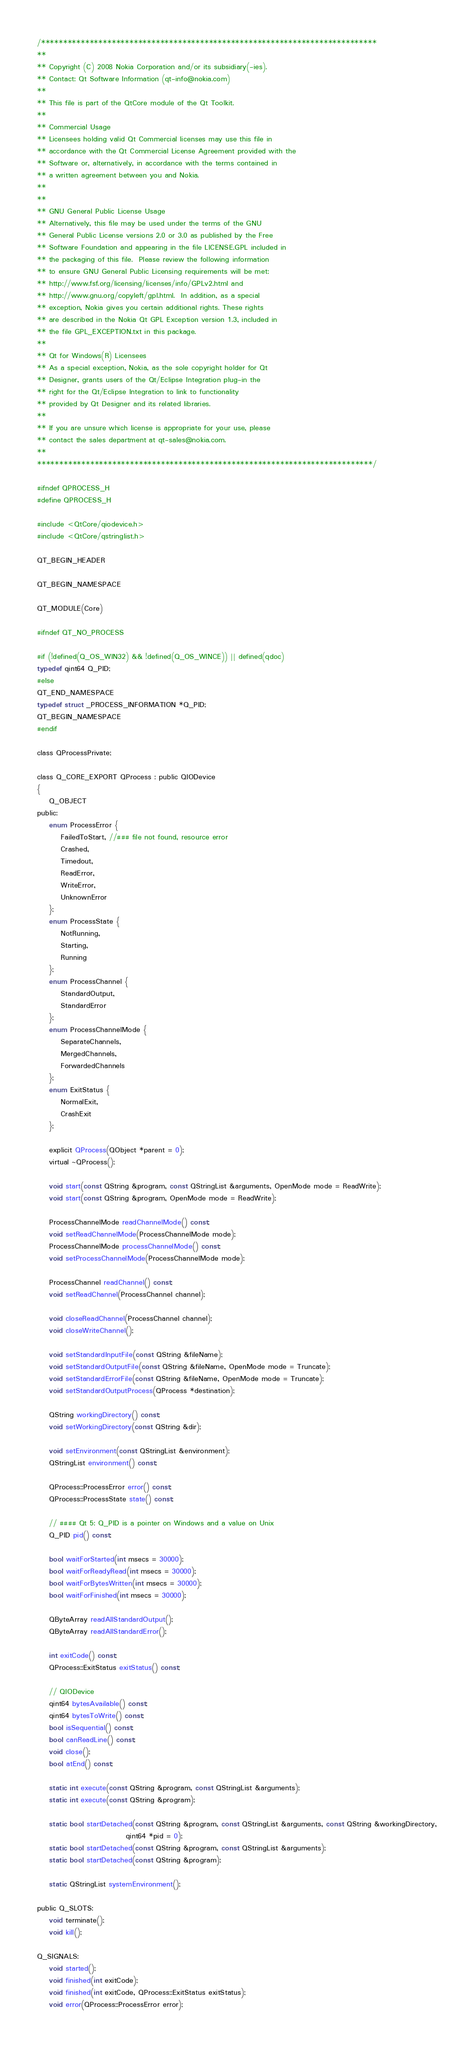Convert code to text. <code><loc_0><loc_0><loc_500><loc_500><_C_>/****************************************************************************
**
** Copyright (C) 2008 Nokia Corporation and/or its subsidiary(-ies).
** Contact: Qt Software Information (qt-info@nokia.com)
**
** This file is part of the QtCore module of the Qt Toolkit.
**
** Commercial Usage
** Licensees holding valid Qt Commercial licenses may use this file in
** accordance with the Qt Commercial License Agreement provided with the
** Software or, alternatively, in accordance with the terms contained in
** a written agreement between you and Nokia.
**
**
** GNU General Public License Usage
** Alternatively, this file may be used under the terms of the GNU
** General Public License versions 2.0 or 3.0 as published by the Free
** Software Foundation and appearing in the file LICENSE.GPL included in
** the packaging of this file.  Please review the following information
** to ensure GNU General Public Licensing requirements will be met:
** http://www.fsf.org/licensing/licenses/info/GPLv2.html and
** http://www.gnu.org/copyleft/gpl.html.  In addition, as a special
** exception, Nokia gives you certain additional rights. These rights
** are described in the Nokia Qt GPL Exception version 1.3, included in
** the file GPL_EXCEPTION.txt in this package.
**
** Qt for Windows(R) Licensees
** As a special exception, Nokia, as the sole copyright holder for Qt
** Designer, grants users of the Qt/Eclipse Integration plug-in the
** right for the Qt/Eclipse Integration to link to functionality
** provided by Qt Designer and its related libraries.
**
** If you are unsure which license is appropriate for your use, please
** contact the sales department at qt-sales@nokia.com.
**
****************************************************************************/

#ifndef QPROCESS_H
#define QPROCESS_H

#include <QtCore/qiodevice.h>
#include <QtCore/qstringlist.h>

QT_BEGIN_HEADER

QT_BEGIN_NAMESPACE

QT_MODULE(Core)

#ifndef QT_NO_PROCESS

#if (!defined(Q_OS_WIN32) && !defined(Q_OS_WINCE)) || defined(qdoc)
typedef qint64 Q_PID;
#else
QT_END_NAMESPACE
typedef struct _PROCESS_INFORMATION *Q_PID;
QT_BEGIN_NAMESPACE
#endif

class QProcessPrivate;

class Q_CORE_EXPORT QProcess : public QIODevice
{
    Q_OBJECT
public:
    enum ProcessError {
        FailedToStart, //### file not found, resource error
        Crashed,
        Timedout,
        ReadError,
        WriteError,
        UnknownError
    };
    enum ProcessState {
        NotRunning,
        Starting,
        Running
    };
    enum ProcessChannel {
        StandardOutput,
        StandardError
    };
    enum ProcessChannelMode {
        SeparateChannels,
        MergedChannels,
        ForwardedChannels
    };
    enum ExitStatus {
        NormalExit,
        CrashExit
    };

    explicit QProcess(QObject *parent = 0);
    virtual ~QProcess();

    void start(const QString &program, const QStringList &arguments, OpenMode mode = ReadWrite);
    void start(const QString &program, OpenMode mode = ReadWrite);

    ProcessChannelMode readChannelMode() const;
    void setReadChannelMode(ProcessChannelMode mode);
    ProcessChannelMode processChannelMode() const;
    void setProcessChannelMode(ProcessChannelMode mode);

    ProcessChannel readChannel() const;
    void setReadChannel(ProcessChannel channel);

    void closeReadChannel(ProcessChannel channel);
    void closeWriteChannel();

    void setStandardInputFile(const QString &fileName);
    void setStandardOutputFile(const QString &fileName, OpenMode mode = Truncate);
    void setStandardErrorFile(const QString &fileName, OpenMode mode = Truncate);
    void setStandardOutputProcess(QProcess *destination);

    QString workingDirectory() const;
    void setWorkingDirectory(const QString &dir);

    void setEnvironment(const QStringList &environment);
    QStringList environment() const;

    QProcess::ProcessError error() const;
    QProcess::ProcessState state() const;

    // #### Qt 5: Q_PID is a pointer on Windows and a value on Unix
    Q_PID pid() const;

    bool waitForStarted(int msecs = 30000);
    bool waitForReadyRead(int msecs = 30000);
    bool waitForBytesWritten(int msecs = 30000);
    bool waitForFinished(int msecs = 30000);

    QByteArray readAllStandardOutput();
    QByteArray readAllStandardError();

    int exitCode() const;
    QProcess::ExitStatus exitStatus() const;

    // QIODevice
    qint64 bytesAvailable() const;
    qint64 bytesToWrite() const;
    bool isSequential() const;
    bool canReadLine() const;
    void close();
    bool atEnd() const;

    static int execute(const QString &program, const QStringList &arguments);
    static int execute(const QString &program);

    static bool startDetached(const QString &program, const QStringList &arguments, const QString &workingDirectory,
                              qint64 *pid = 0);
    static bool startDetached(const QString &program, const QStringList &arguments);
    static bool startDetached(const QString &program);

    static QStringList systemEnvironment();

public Q_SLOTS:
    void terminate();
    void kill();

Q_SIGNALS:
    void started();
    void finished(int exitCode);
    void finished(int exitCode, QProcess::ExitStatus exitStatus);
    void error(QProcess::ProcessError error);</code> 